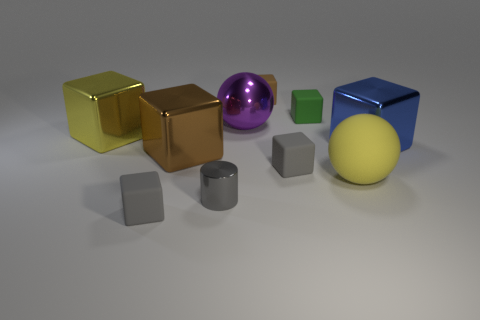How many big yellow spheres are on the left side of the gray cube in front of the yellow object that is to the right of the small green matte thing?
Ensure brevity in your answer.  0. Is the number of small gray shiny things that are right of the large blue cube the same as the number of tiny brown cubes that are in front of the yellow block?
Your response must be concise. Yes. How many small gray shiny things have the same shape as the blue metal thing?
Your answer should be compact. 0. Is there a tiny brown block made of the same material as the big brown cube?
Make the answer very short. No. There is a big thing that is the same color as the matte sphere; what is its shape?
Your answer should be compact. Cube. How many small matte cylinders are there?
Give a very brief answer. 0. How many cylinders are either large brown objects or big rubber objects?
Offer a very short reply. 0. What color is the metallic ball that is the same size as the yellow shiny thing?
Keep it short and to the point. Purple. What number of objects are on the left side of the big brown block and in front of the yellow rubber ball?
Keep it short and to the point. 1. What is the tiny gray cylinder made of?
Offer a terse response. Metal. 